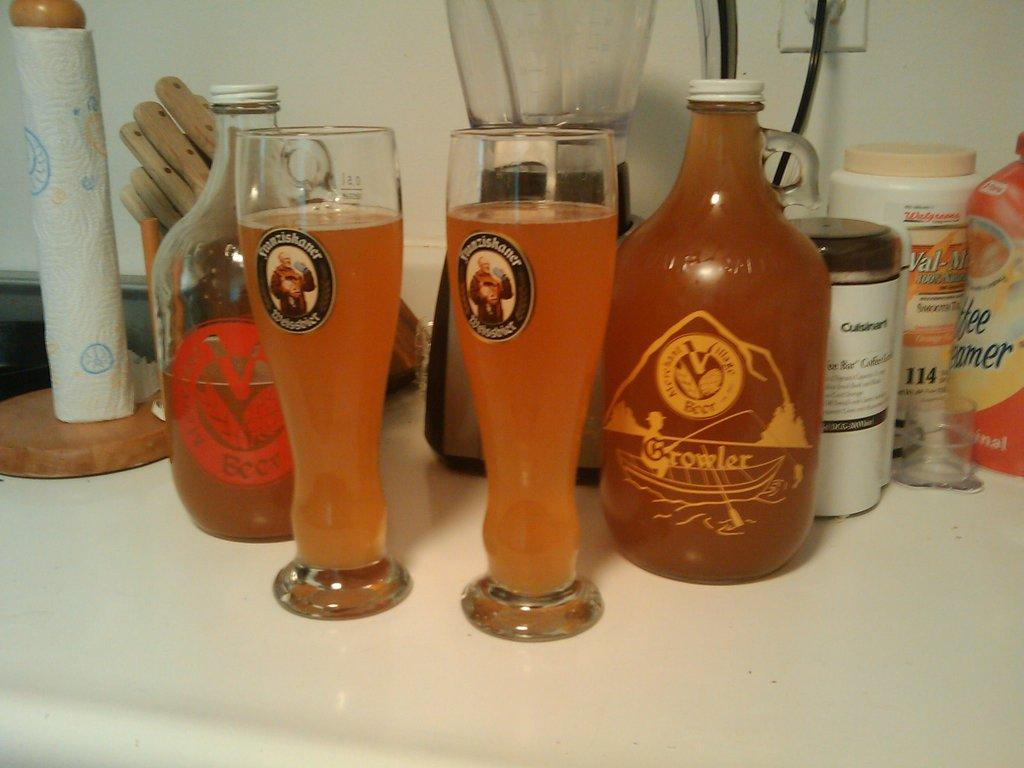<image>
Present a compact description of the photo's key features. Two large glasses of beer sit next to a bottle that says Growler on its front. 